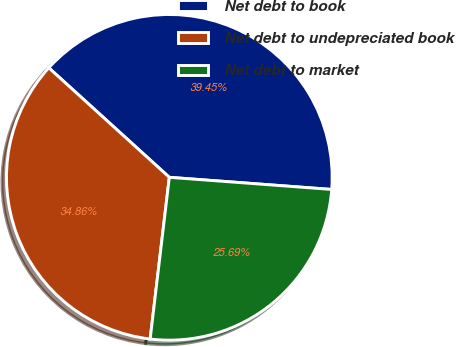Convert chart. <chart><loc_0><loc_0><loc_500><loc_500><pie_chart><fcel>Net debt to book<fcel>Net debt to undepreciated book<fcel>Net debt to market<nl><fcel>39.45%<fcel>34.86%<fcel>25.69%<nl></chart> 